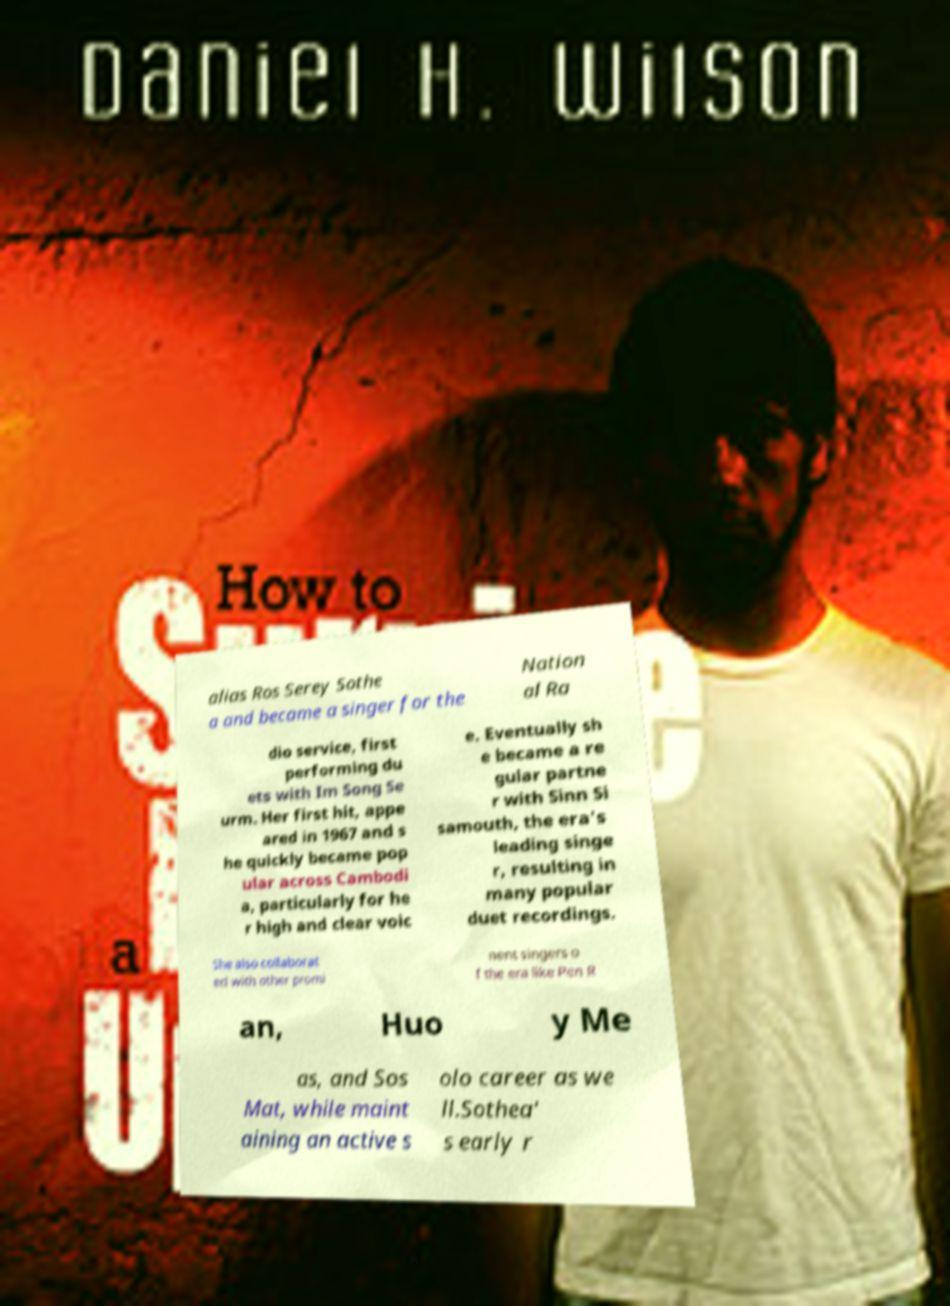Please identify and transcribe the text found in this image. alias Ros Serey Sothe a and became a singer for the Nation al Ra dio service, first performing du ets with Im Song Se urm. Her first hit, appe ared in 1967 and s he quickly became pop ular across Cambodi a, particularly for he r high and clear voic e. Eventually sh e became a re gular partne r with Sinn Si samouth, the era's leading singe r, resulting in many popular duet recordings. She also collaborat ed with other promi nent singers o f the era like Pen R an, Huo y Me as, and Sos Mat, while maint aining an active s olo career as we ll.Sothea' s early r 